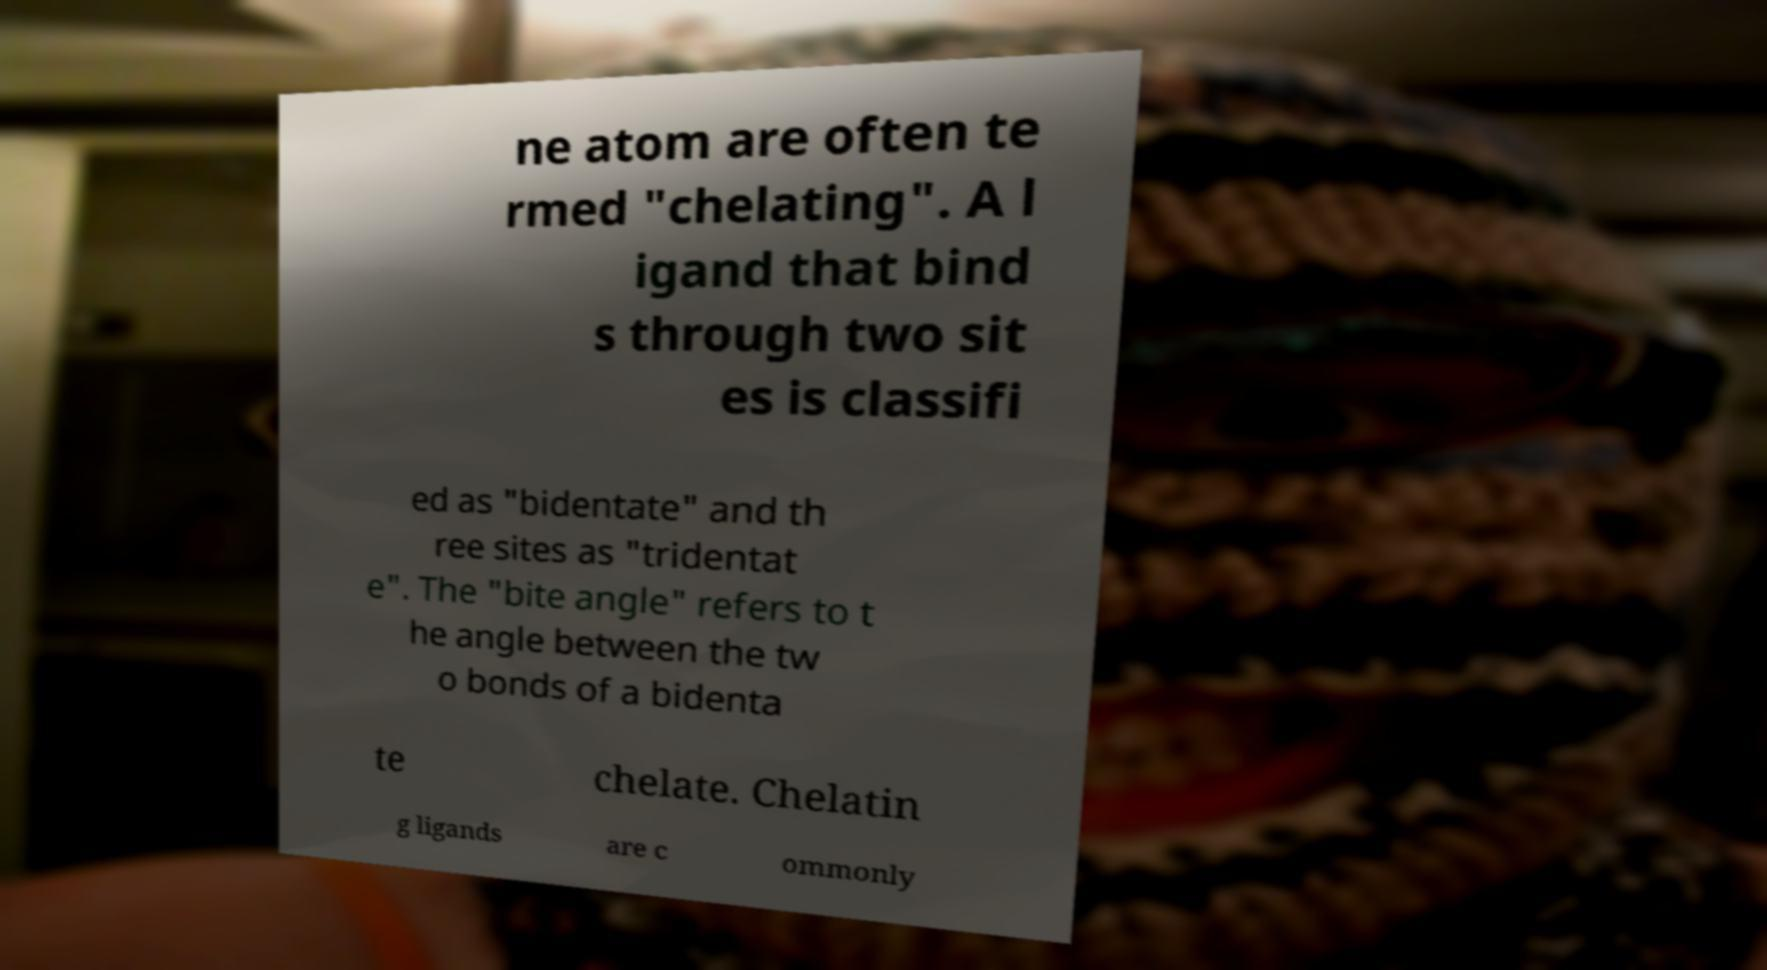Please read and relay the text visible in this image. What does it say? ne atom are often te rmed "chelating". A l igand that bind s through two sit es is classifi ed as "bidentate" and th ree sites as "tridentat e". The "bite angle" refers to t he angle between the tw o bonds of a bidenta te chelate. Chelatin g ligands are c ommonly 